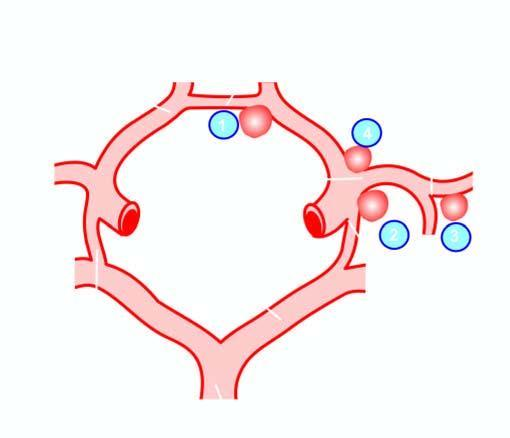do the serial numbers indicate the frequency of involvement?
Answer the question using a single word or phrase. Yes 